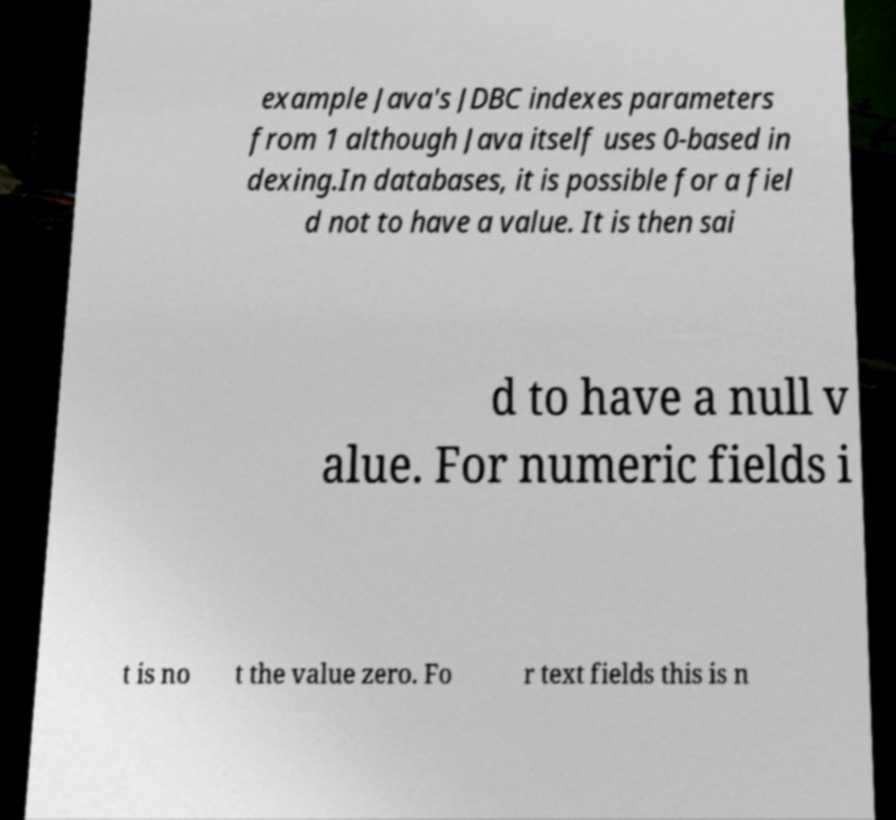What messages or text are displayed in this image? I need them in a readable, typed format. example Java's JDBC indexes parameters from 1 although Java itself uses 0-based in dexing.In databases, it is possible for a fiel d not to have a value. It is then sai d to have a null v alue. For numeric fields i t is no t the value zero. Fo r text fields this is n 